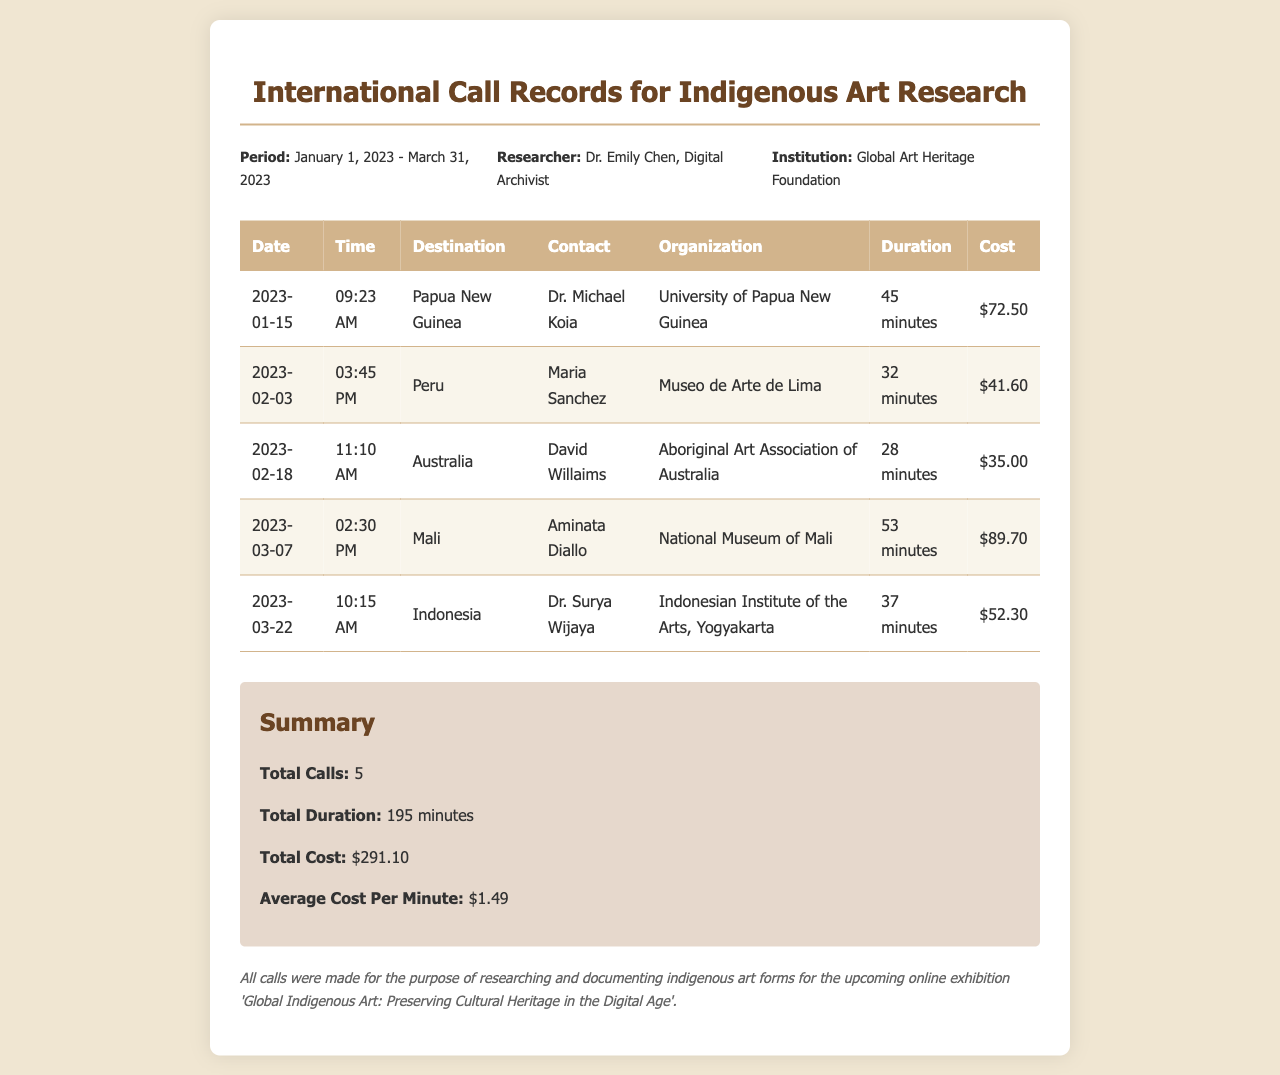What is the total cost of all calls? The total cost is calculated by summing the costs of each individual call listed in the document, which is $72.50 + $41.60 + $35.00 + $89.70 + $52.30 = $291.10.
Answer: $291.10 Who was contacted for the call to Papua New Guinea? The document specifies that Dr. Michael Koia was the contact during the call to Papua New Guinea.
Answer: Dr. Michael Koia What is the duration of the call made to Mali? The information provided states that the call to Mali lasted for 53 minutes.
Answer: 53 minutes Which organization is associated with the contact in Peru? The Museo de Arte de Lima is mentioned as the organization associated with Maria Sanchez in the call to Peru.
Answer: Museo de Arte de Lima What was the average cost per minute for the international calls? To find the average cost per minute, the total cost ($291.10) is divided by the total duration (195 minutes), resulting in an average cost per minute of $1.49.
Answer: $1.49 How many calls were made in total? The summary in the document states that a total of 5 calls were made during the specified period.
Answer: 5 What destination was contacted on February 18, 2023? The document indicates that Australia was the destination for the contact made on February 18, 2023.
Answer: Australia Which researcher is associated with this document? According to the header information, the researcher associated with the document is Dr. Emily Chen.
Answer: Dr. Emily Chen 